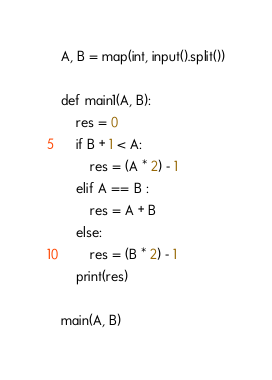Convert code to text. <code><loc_0><loc_0><loc_500><loc_500><_Python_>A, B = map(int, input().split())

def main1(A, B):
    res = 0
    if B + 1 < A:
        res = (A * 2) - 1
    elif A == B :
        res = A + B
    else:
        res = (B * 2) - 1
    print(res)

main(A, B)
</code> 